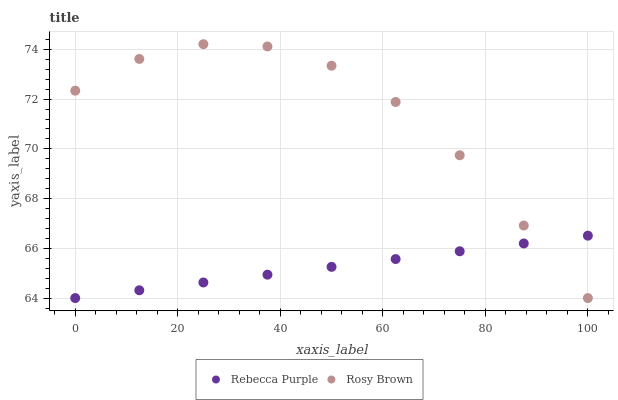Does Rebecca Purple have the minimum area under the curve?
Answer yes or no. Yes. Does Rosy Brown have the maximum area under the curve?
Answer yes or no. Yes. Does Rebecca Purple have the maximum area under the curve?
Answer yes or no. No. Is Rebecca Purple the smoothest?
Answer yes or no. Yes. Is Rosy Brown the roughest?
Answer yes or no. Yes. Is Rebecca Purple the roughest?
Answer yes or no. No. Does Rosy Brown have the lowest value?
Answer yes or no. Yes. Does Rosy Brown have the highest value?
Answer yes or no. Yes. Does Rebecca Purple have the highest value?
Answer yes or no. No. Does Rosy Brown intersect Rebecca Purple?
Answer yes or no. Yes. Is Rosy Brown less than Rebecca Purple?
Answer yes or no. No. Is Rosy Brown greater than Rebecca Purple?
Answer yes or no. No. 